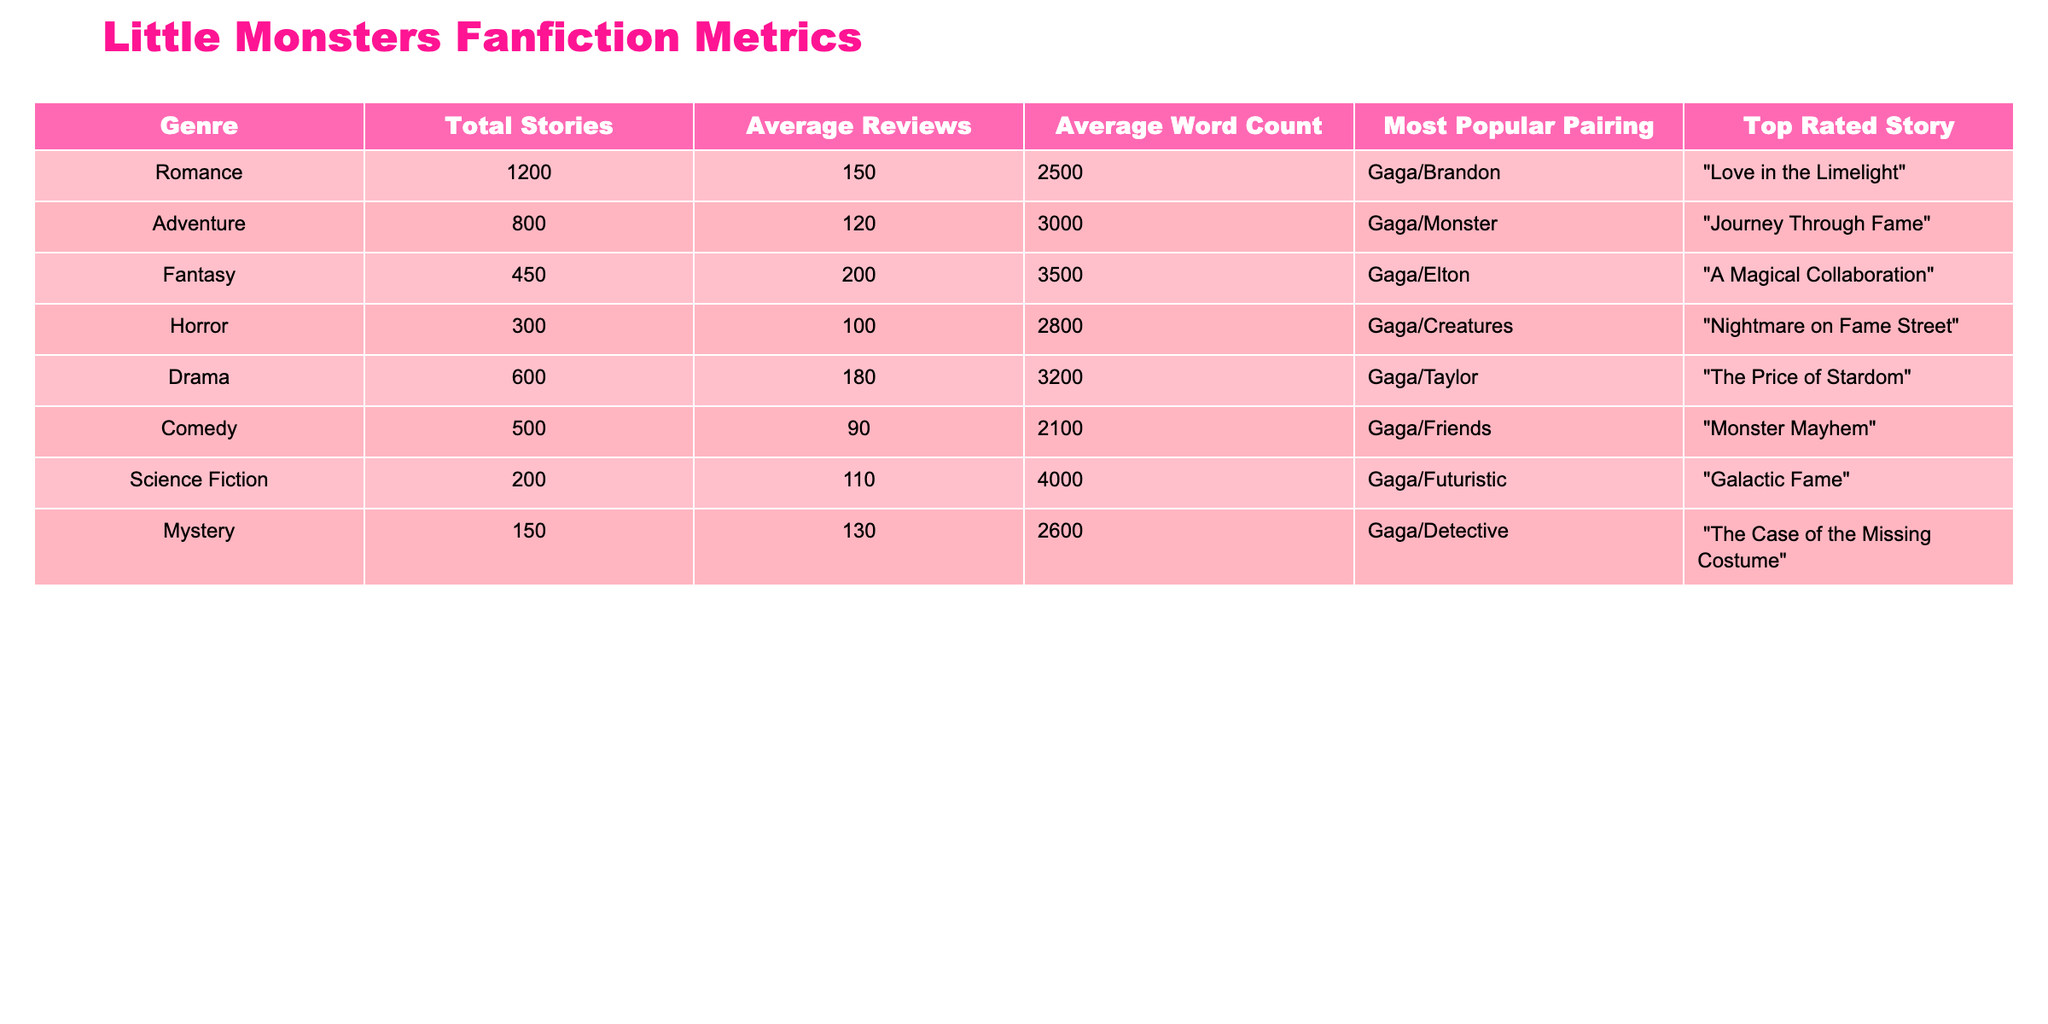What is the most popular pairing in the Romance genre? According to the table, the most popular pairing listed under the Romance genre is "Gaga/Brandon."
Answer: Gaga/Brandon Which genre has the highest average reviews? The highest average reviews can be found by comparing the values in the Average Reviews column. Romance has 150, Drama has 180, and Fantasy has 200. The highest is Fantasy with 200 average reviews.
Answer: Fantasy What is the total word count of stories in the Adventure genre? The total word count for the Adventure genre is given as 3000 (Average Word Count) multiplied by 800 (Total Stories), resulting in a total of 2,400,000 words.
Answer: 2,400,000 Is the average word count for Horror genre stories greater than that of Comedy genre stories? The Average Word Count for Horror is 2800, and for Comedy, it is 2100. Since 2800 is greater than 2100, the statement is true.
Answer: Yes What is the top-rated story in the Science Fiction genre? The table states the top-rated story in the Science Fiction genre is "Galactic Fame."
Answer: Galactic Fame Which genre has the least number of total stories, and what is that number? By checking the Total Stories column, the least number of stories is 150 in the Mystery genre.
Answer: Mystery, 150 If we combine the total stories from the Romance and Drama genres, how many stories do we have in total? The total stories from Romance is 1200 and Drama is 600. Adding these gives 1200 + 600 = 1800 total stories.
Answer: 1800 What is the difference in average reviews between the Fantasy and Horror genres? The average reviews for Fantasy is 200, and for Horror, it is 100. The difference is 200 - 100 = 100.
Answer: 100 Which genre has a most popular pairing of "Gaga/Creatures"? The genre with "Gaga/Creatures" as the most popular pairing is Horror.
Answer: Horror 